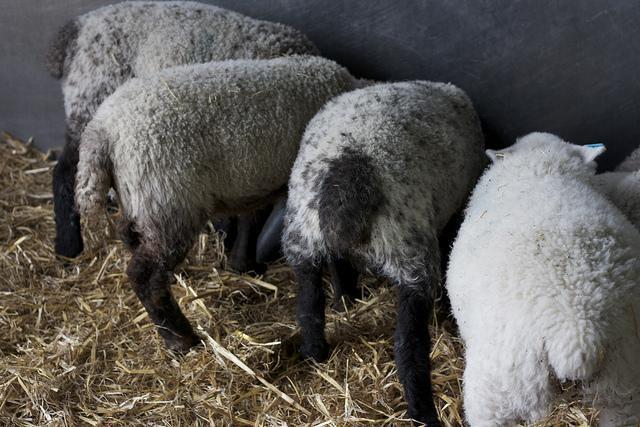How many sheep are there?
Give a very brief answer. 4. 